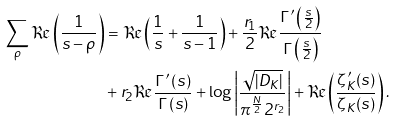<formula> <loc_0><loc_0><loc_500><loc_500>\sum _ { \rho } \Re \left ( \frac { 1 } { s - \rho } \right ) & = \Re \left ( \frac { 1 } { s } + \frac { 1 } { s - 1 } \right ) + \frac { r _ { 1 } } { 2 } \Re \frac { \Gamma ^ { \prime } \left ( \frac { s } { 2 } \right ) } { \Gamma \left ( \frac { s } { 2 } \right ) } \\ & + r _ { 2 } \Re \frac { \Gamma ^ { \prime } \left ( s \right ) } { \Gamma \left ( s \right ) } + \log \left | \frac { \sqrt { | D _ { K } | } } { \pi ^ { \frac { N } { 2 } } 2 ^ { r _ { 2 } } } \right | + \Re \left ( \frac { \zeta ^ { \prime } _ { K } ( s ) } { \zeta _ { K } ( s ) } \right ) .</formula> 